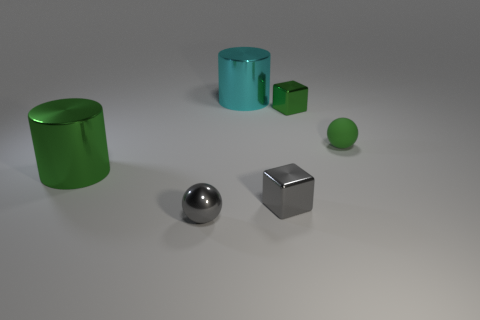Subtract all cylinders. How many objects are left? 4 Add 3 shiny balls. How many objects exist? 9 Subtract all green cylinders. How many cylinders are left? 1 Add 6 gray balls. How many gray balls are left? 7 Add 5 purple rubber objects. How many purple rubber objects exist? 5 Subtract 0 brown cylinders. How many objects are left? 6 Subtract 1 cylinders. How many cylinders are left? 1 Subtract all purple cubes. Subtract all purple cylinders. How many cubes are left? 2 Subtract all green spheres. How many yellow cylinders are left? 0 Subtract all metal objects. Subtract all large red matte cubes. How many objects are left? 1 